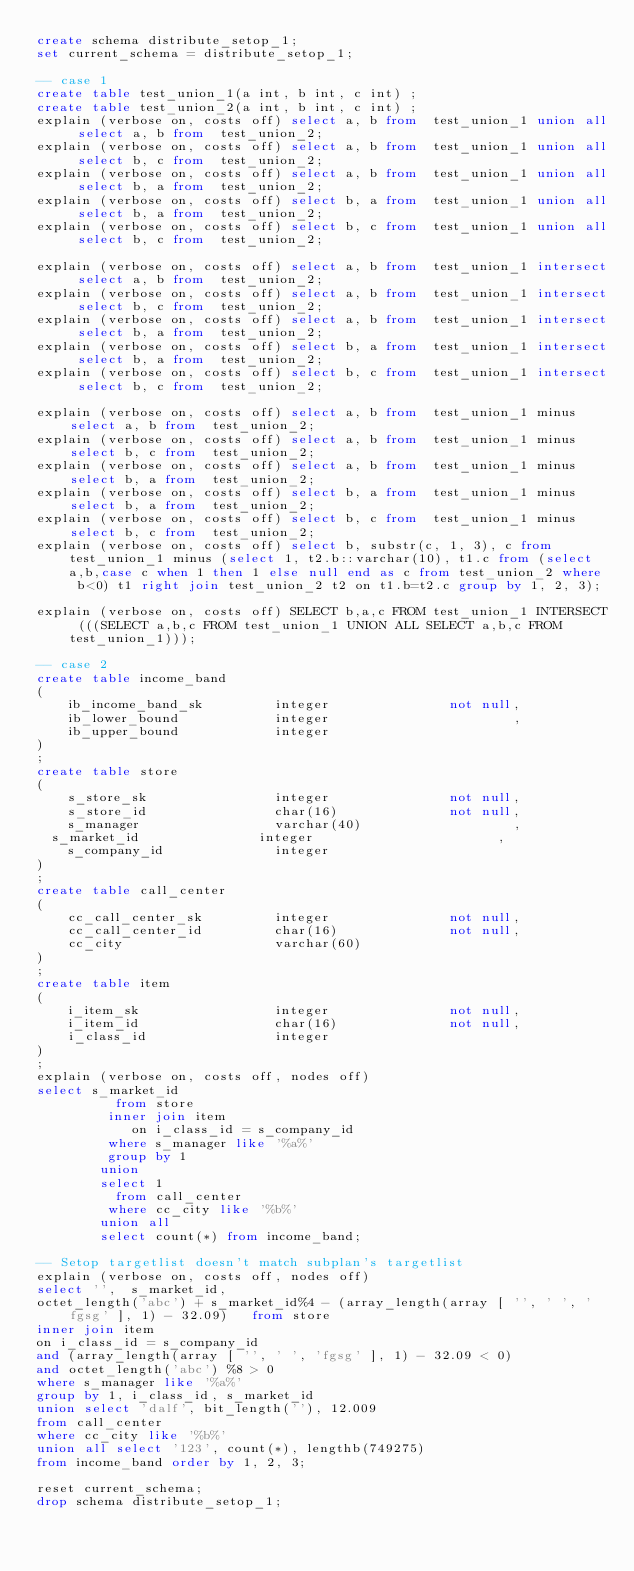Convert code to text. <code><loc_0><loc_0><loc_500><loc_500><_SQL_>create schema distribute_setop_1;
set current_schema = distribute_setop_1;

-- case 1
create table test_union_1(a int, b int, c int) ;
create table test_union_2(a int, b int, c int) ;
explain (verbose on, costs off) select a, b from  test_union_1 union all select a, b from  test_union_2;
explain (verbose on, costs off) select a, b from  test_union_1 union all select b, c from  test_union_2;
explain (verbose on, costs off) select a, b from  test_union_1 union all select b, a from  test_union_2;
explain (verbose on, costs off) select b, a from  test_union_1 union all select b, a from  test_union_2;
explain (verbose on, costs off) select b, c from  test_union_1 union all select b, c from  test_union_2;

explain (verbose on, costs off) select a, b from  test_union_1 intersect select a, b from  test_union_2;
explain (verbose on, costs off) select a, b from  test_union_1 intersect select b, c from  test_union_2;
explain (verbose on, costs off) select a, b from  test_union_1 intersect select b, a from  test_union_2;
explain (verbose on, costs off) select b, a from  test_union_1 intersect select b, a from  test_union_2;
explain (verbose on, costs off) select b, c from  test_union_1 intersect select b, c from  test_union_2;

explain (verbose on, costs off) select a, b from  test_union_1 minus select a, b from  test_union_2;
explain (verbose on, costs off) select a, b from  test_union_1 minus select b, c from  test_union_2;
explain (verbose on, costs off) select a, b from  test_union_1 minus select b, a from  test_union_2;
explain (verbose on, costs off) select b, a from  test_union_1 minus select b, a from  test_union_2;
explain (verbose on, costs off) select b, c from  test_union_1 minus select b, c from  test_union_2;
explain (verbose on, costs off) select b, substr(c, 1, 3), c from  test_union_1 minus (select 1, t2.b::varchar(10), t1.c from (select a,b,case c when 1 then 1 else null end as c from test_union_2 where b<0) t1 right join test_union_2 t2 on t1.b=t2.c group by 1, 2, 3);

explain (verbose on, costs off) SELECT b,a,c FROM test_union_1 INTERSECT (((SELECT a,b,c FROM test_union_1 UNION ALL SELECT a,b,c FROM test_union_1)));

-- case 2
create table income_band
(
    ib_income_band_sk         integer               not null,
    ib_lower_bound            integer                       ,
    ib_upper_bound            integer
)
;
create table store
(
    s_store_sk                integer               not null,
    s_store_id                char(16)              not null,
    s_manager                 varchar(40)                   ,
	s_market_id               integer                       ,
    s_company_id              integer
)
;
create table call_center
(
    cc_call_center_sk         integer               not null,
    cc_call_center_id         char(16)              not null,
    cc_city                   varchar(60)
)
;
create table item
(
    i_item_sk                 integer               not null,
    i_item_id                 char(16)              not null,
    i_class_id                integer
)
;
explain (verbose on, costs off, nodes off)
select s_market_id
          from store
         inner join item
            on i_class_id = s_company_id
         where s_manager like '%a%'
         group by 1
        union
        select 1
          from call_center
         where cc_city like '%b%'
        union all 
        select count(*) from income_band;

-- Setop targetlist doesn't match subplan's targetlist
explain (verbose on, costs off, nodes off)
select '',  s_market_id,
octet_length('abc') + s_market_id%4 - (array_length(array [ '', ' ', 'fgsg' ], 1) - 32.09)   from store
inner join item
on i_class_id = s_company_id
and (array_length(array [ '', ' ', 'fgsg' ], 1) - 32.09 < 0)
and octet_length('abc') %8 > 0
where s_manager like '%a%'
group by 1, i_class_id, s_market_id
union select 'dalf', bit_length(''), 12.009
from call_center
where cc_city like '%b%'
union all select '123', count(*), lengthb(749275)
from income_band order by 1, 2, 3;

reset current_schema;
drop schema distribute_setop_1;
</code> 